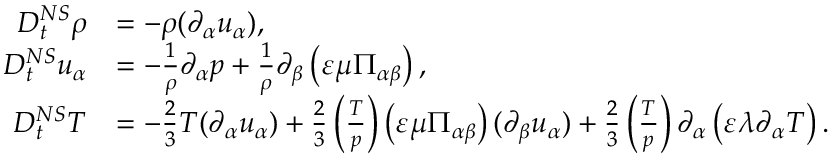<formula> <loc_0><loc_0><loc_500><loc_500>\begin{array} { r l } { D _ { t } ^ { N S } \rho } & { = - \rho ( \partial _ { \alpha } u _ { \alpha } ) , } \\ { D _ { t } ^ { N S } u _ { \alpha } } & { = - \frac { 1 } { \rho } \partial _ { \alpha } p + \frac { 1 } { \rho } \partial _ { \beta } \left ( \varepsilon \mu \Pi _ { \alpha \beta } \right ) , } \\ { D _ { t } ^ { N S } T } & { = - \frac { 2 } { 3 } T ( \partial _ { \alpha } u _ { \alpha } ) + \frac { 2 } { 3 } \left ( \frac { T } { p } \right ) \left ( \varepsilon \mu \Pi _ { \alpha \beta } \right ) ( \partial _ { \beta } u _ { \alpha } ) + \frac { 2 } { 3 } \left ( \frac { T } { p } \right ) \partial _ { \alpha } \left ( \varepsilon \lambda \partial _ { \alpha } T \right ) . } \end{array}</formula> 